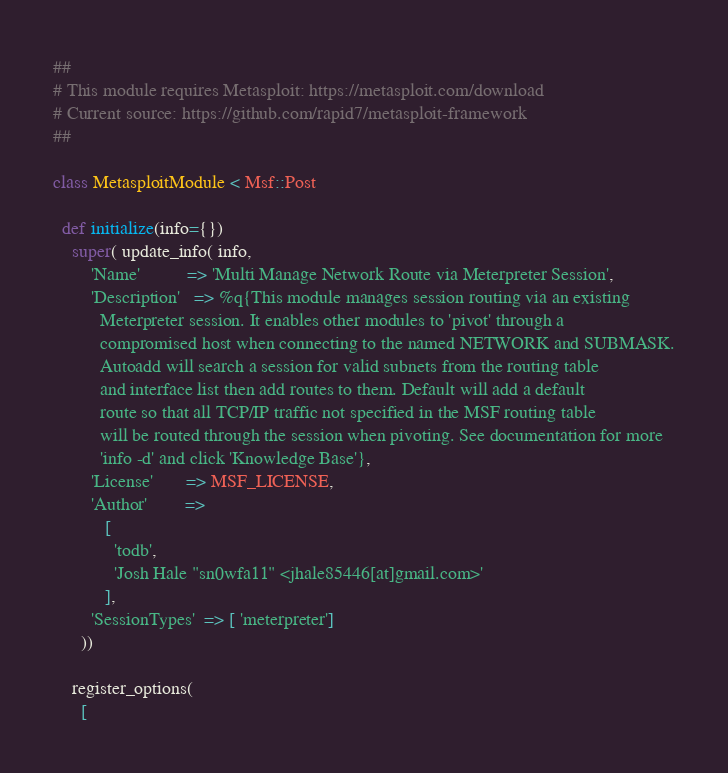Convert code to text. <code><loc_0><loc_0><loc_500><loc_500><_Ruby_>##
# This module requires Metasploit: https://metasploit.com/download
# Current source: https://github.com/rapid7/metasploit-framework
##

class MetasploitModule < Msf::Post

  def initialize(info={})
    super( update_info( info,
        'Name'          => 'Multi Manage Network Route via Meterpreter Session',
        'Description'   => %q{This module manages session routing via an existing
          Meterpreter session. It enables other modules to 'pivot' through a
          compromised host when connecting to the named NETWORK and SUBMASK.
          Autoadd will search a session for valid subnets from the routing table
          and interface list then add routes to them. Default will add a default
          route so that all TCP/IP traffic not specified in the MSF routing table
          will be routed through the session when pivoting. See documentation for more
          'info -d' and click 'Knowledge Base'},
        'License'       => MSF_LICENSE,
        'Author'        =>
           [
             'todb',
             'Josh Hale "sn0wfa11" <jhale85446[at]gmail.com>'
           ],
        'SessionTypes'  => [ 'meterpreter']
      ))

    register_options(
      [</code> 